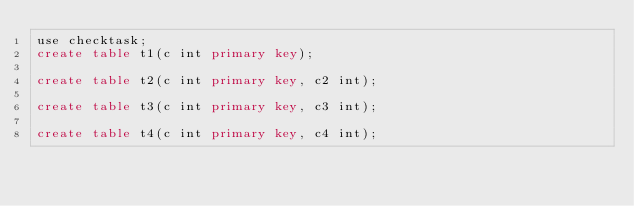Convert code to text. <code><loc_0><loc_0><loc_500><loc_500><_SQL_>use checktask;
create table t1(c int primary key);

create table t2(c int primary key, c2 int);

create table t3(c int primary key, c3 int);

create table t4(c int primary key, c4 int);
</code> 